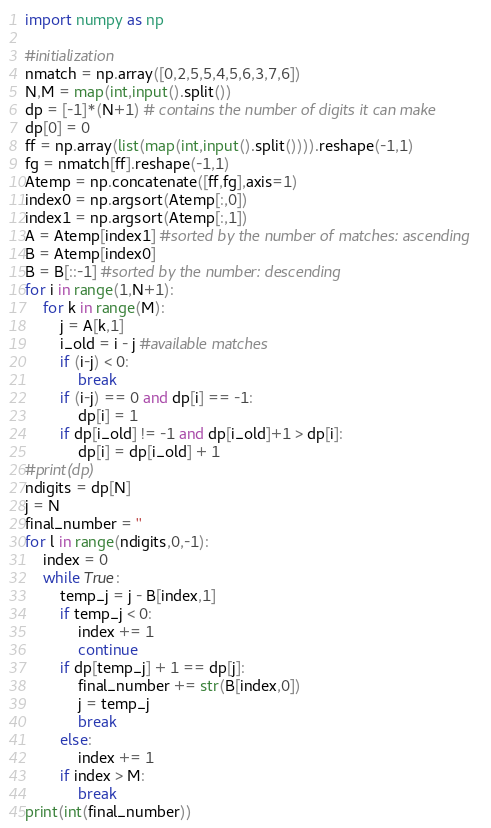<code> <loc_0><loc_0><loc_500><loc_500><_Python_>import numpy as np

#initialization
nmatch = np.array([0,2,5,5,4,5,6,3,7,6])
N,M = map(int,input().split())
dp = [-1]*(N+1) # contains the number of digits it can make
dp[0] = 0
ff = np.array(list(map(int,input().split()))).reshape(-1,1)
fg = nmatch[ff].reshape(-1,1)
Atemp = np.concatenate([ff,fg],axis=1)
index0 = np.argsort(Atemp[:,0])
index1 = np.argsort(Atemp[:,1])
A = Atemp[index1] #sorted by the number of matches: ascending
B = Atemp[index0]
B = B[::-1] #sorted by the number: descending
for i in range(1,N+1):
    for k in range(M):
        j = A[k,1]
        i_old = i - j #available matches
        if (i-j) < 0:
            break
        if (i-j) == 0 and dp[i] == -1:
            dp[i] = 1
        if dp[i_old] != -1 and dp[i_old]+1 > dp[i]:
            dp[i] = dp[i_old] + 1
#print(dp)
ndigits = dp[N]
j = N
final_number = ''
for l in range(ndigits,0,-1):
    index = 0
    while True:
        temp_j = j - B[index,1]
        if temp_j < 0:
            index += 1
            continue
        if dp[temp_j] + 1 == dp[j]:
            final_number += str(B[index,0])
            j = temp_j
            break
        else:
            index += 1
        if index > M:
            break
print(int(final_number))
</code> 